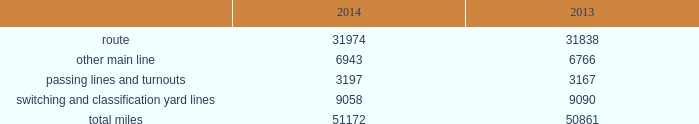Item 1b .
Unresolved staff comments item 2 .
Properties we employ a variety of assets in the management and operation of our rail business .
Our rail network covers 23 states in the western two-thirds of the u.s .
Our rail network includes 31974 route miles .
We own 26012 miles and operate on the remainder pursuant to trackage rights or leases .
The table describes track miles at december 31 , 2014 and 2013 .
2014 2013 .
Headquarters building we own our headquarters building in omaha , nebraska .
The facility has 1.2 million square feet of space for approximately 4000 employees. .
What is the average number of total track miles per state in the rail network ? 
Computations: (51172 / 23)
Answer: 2224.86957. 